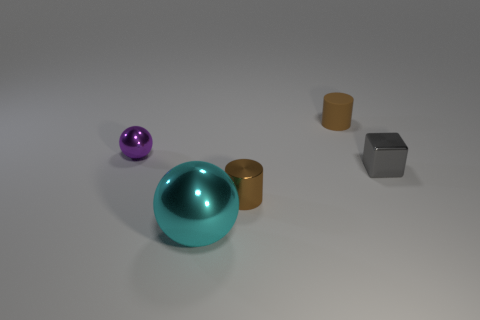Add 3 tiny objects. How many objects exist? 8 Subtract all blocks. How many objects are left? 4 Add 3 large green cylinders. How many large green cylinders exist? 3 Subtract 1 gray blocks. How many objects are left? 4 Subtract all big metal things. Subtract all large metallic blocks. How many objects are left? 4 Add 5 brown shiny cylinders. How many brown shiny cylinders are left? 6 